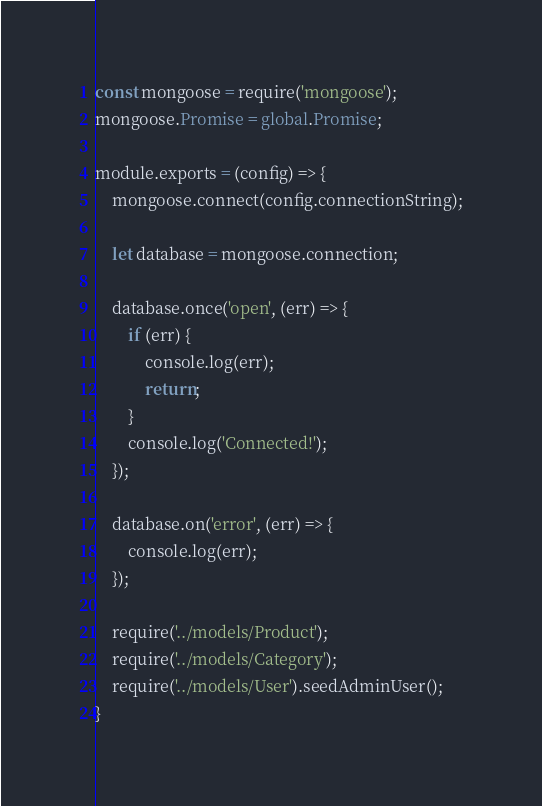<code> <loc_0><loc_0><loc_500><loc_500><_JavaScript_>const mongoose = require('mongoose');
mongoose.Promise = global.Promise;

module.exports = (config) => {
    mongoose.connect(config.connectionString);

    let database = mongoose.connection;

    database.once('open', (err) => {
        if (err) {
            console.log(err);
            return;
        }
        console.log('Connected!');
    });

    database.on('error', (err) => {
        console.log(err);
    });

    require('../models/Product');
    require('../models/Category');
    require('../models/User').seedAdminUser();
}</code> 